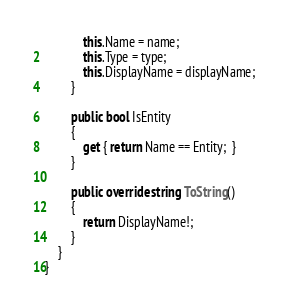Convert code to text. <code><loc_0><loc_0><loc_500><loc_500><_C#_>            this.Name = name;
            this.Type = type;
            this.DisplayName = displayName;
        }

        public bool IsEntity
        {
            get { return Name == Entity;  }
        }

        public override string ToString()
        {
            return DisplayName!;
        }
    }
}
</code> 